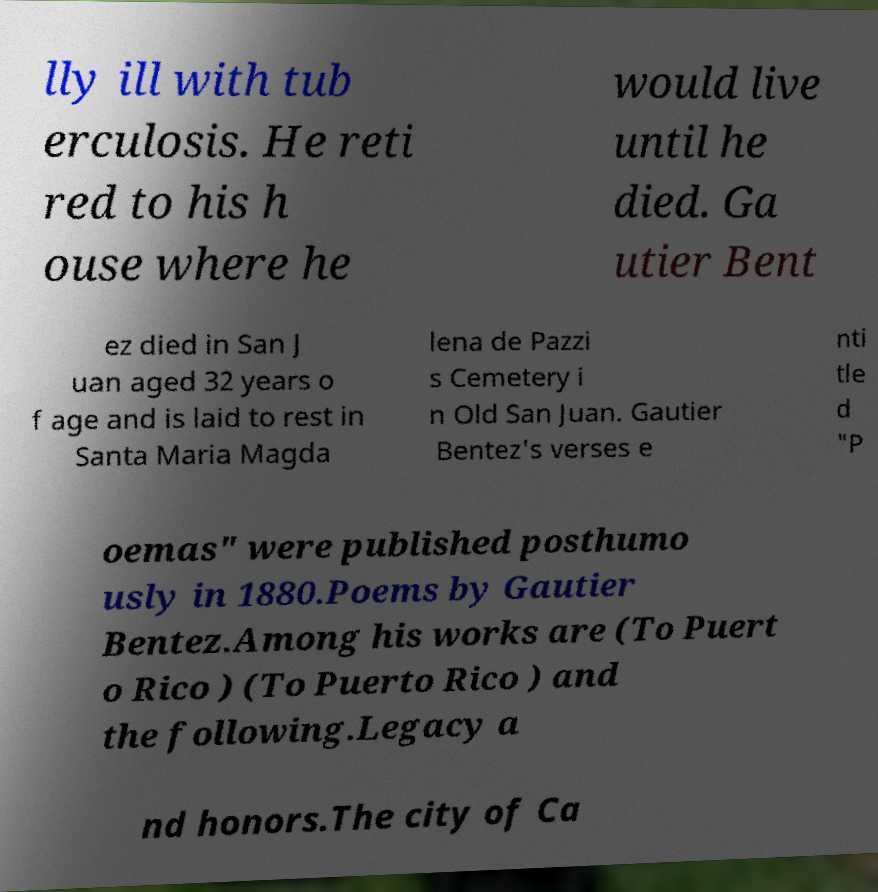What messages or text are displayed in this image? I need them in a readable, typed format. lly ill with tub erculosis. He reti red to his h ouse where he would live until he died. Ga utier Bent ez died in San J uan aged 32 years o f age and is laid to rest in Santa Maria Magda lena de Pazzi s Cemetery i n Old San Juan. Gautier Bentez's verses e nti tle d "P oemas" were published posthumo usly in 1880.Poems by Gautier Bentez.Among his works are (To Puert o Rico ) (To Puerto Rico ) and the following.Legacy a nd honors.The city of Ca 